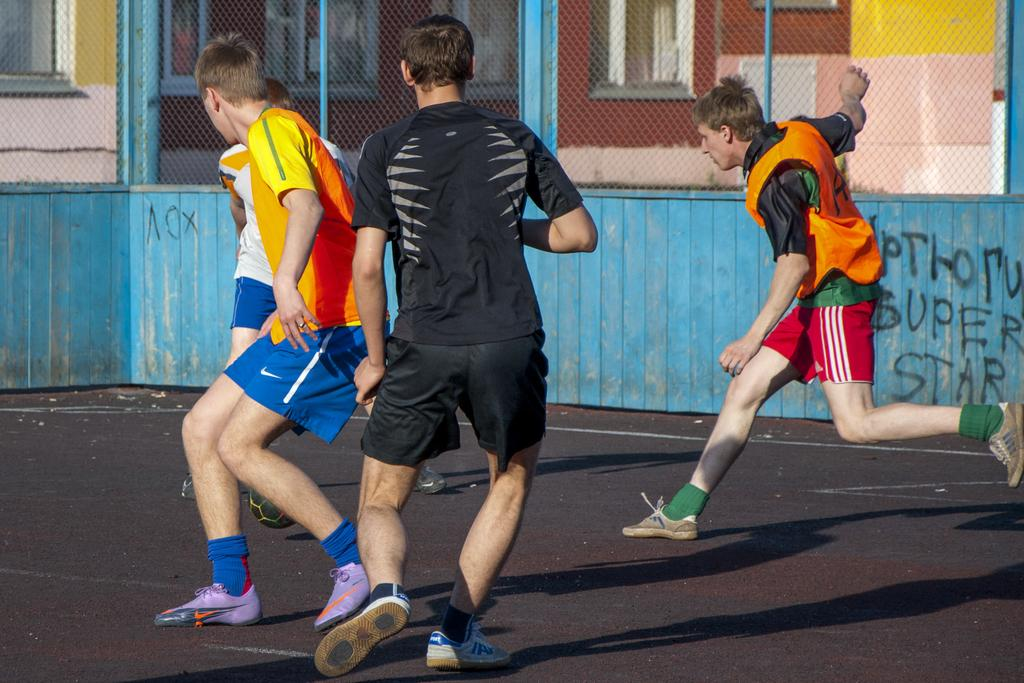<image>
Relay a brief, clear account of the picture shown. people playing soccer outside in front of a blue wall with Super Star on it 